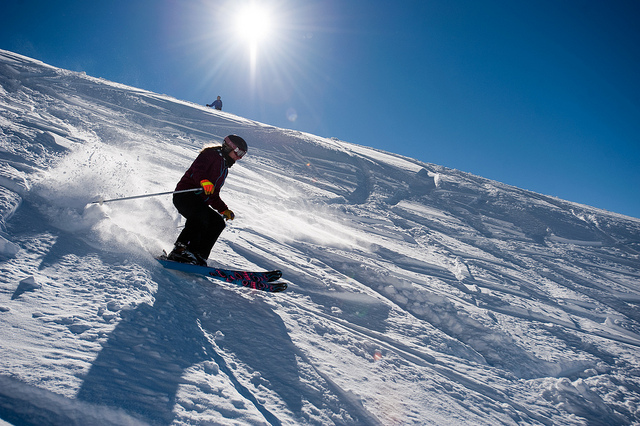<image>What is the grade of this steep hill? It's not clear what the grade of the hill is. It could be 45 degrees or not as specified. What is the grade of this steep hill? I don't know the grade of this steep hill. It can be both pretty steep or 45 degrees. 